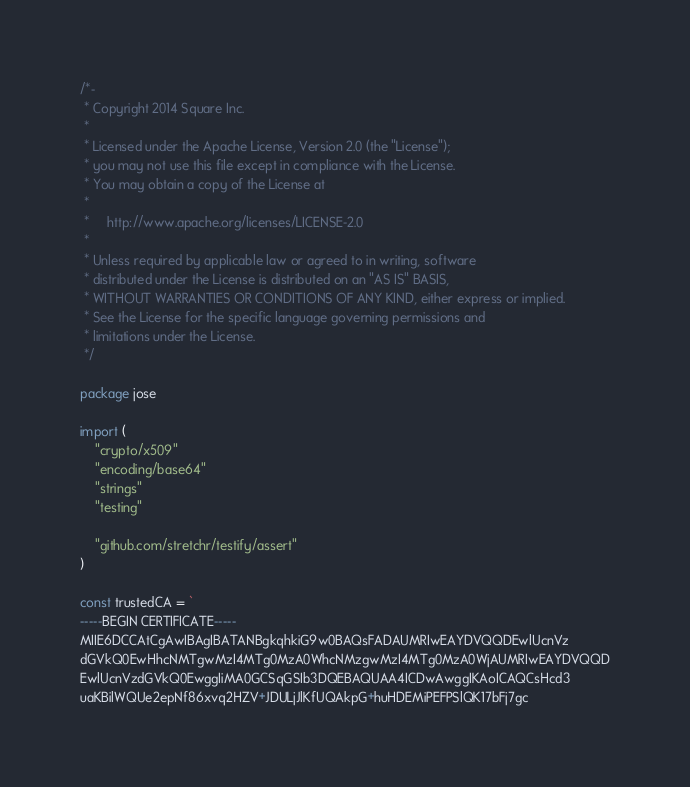Convert code to text. <code><loc_0><loc_0><loc_500><loc_500><_Go_>/*-
 * Copyright 2014 Square Inc.
 *
 * Licensed under the Apache License, Version 2.0 (the "License");
 * you may not use this file except in compliance with the License.
 * You may obtain a copy of the License at
 *
 *     http://www.apache.org/licenses/LICENSE-2.0
 *
 * Unless required by applicable law or agreed to in writing, software
 * distributed under the License is distributed on an "AS IS" BASIS,
 * WITHOUT WARRANTIES OR CONDITIONS OF ANY KIND, either express or implied.
 * See the License for the specific language governing permissions and
 * limitations under the License.
 */

package jose

import (
	"crypto/x509"
	"encoding/base64"
	"strings"
	"testing"

	"github.com/stretchr/testify/assert"
)

const trustedCA = `
-----BEGIN CERTIFICATE-----
MIIE6DCCAtCgAwIBAgIBATANBgkqhkiG9w0BAQsFADAUMRIwEAYDVQQDEwlUcnVz
dGVkQ0EwHhcNMTgwMzI4MTg0MzA0WhcNMzgwMzI4MTg0MzA0WjAUMRIwEAYDVQQD
EwlUcnVzdGVkQ0EwggIiMA0GCSqGSIb3DQEBAQUAA4ICDwAwggIKAoICAQCsHcd3
uaKBilWQUe2epNf86xvq2HZV+JDULjJlKfUQAkpG+huHDEMiPEFPSlQK17bFj7gc</code> 